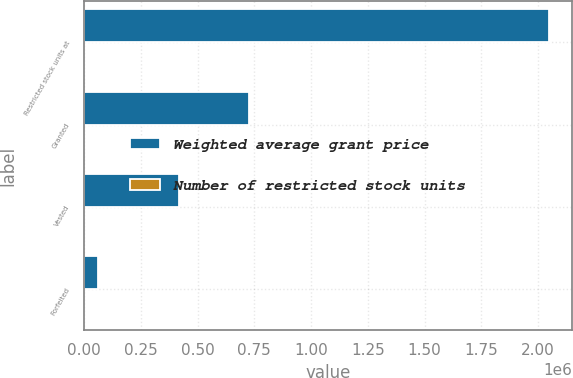Convert chart to OTSL. <chart><loc_0><loc_0><loc_500><loc_500><stacked_bar_chart><ecel><fcel>Restricted stock units at<fcel>Granted<fcel>Vested<fcel>Forfeited<nl><fcel>Weighted average grant price<fcel>2.04716e+06<fcel>727300<fcel>416755<fcel>63163<nl><fcel>Number of restricted stock units<fcel>25.08<fcel>28.81<fcel>22.26<fcel>25.48<nl></chart> 